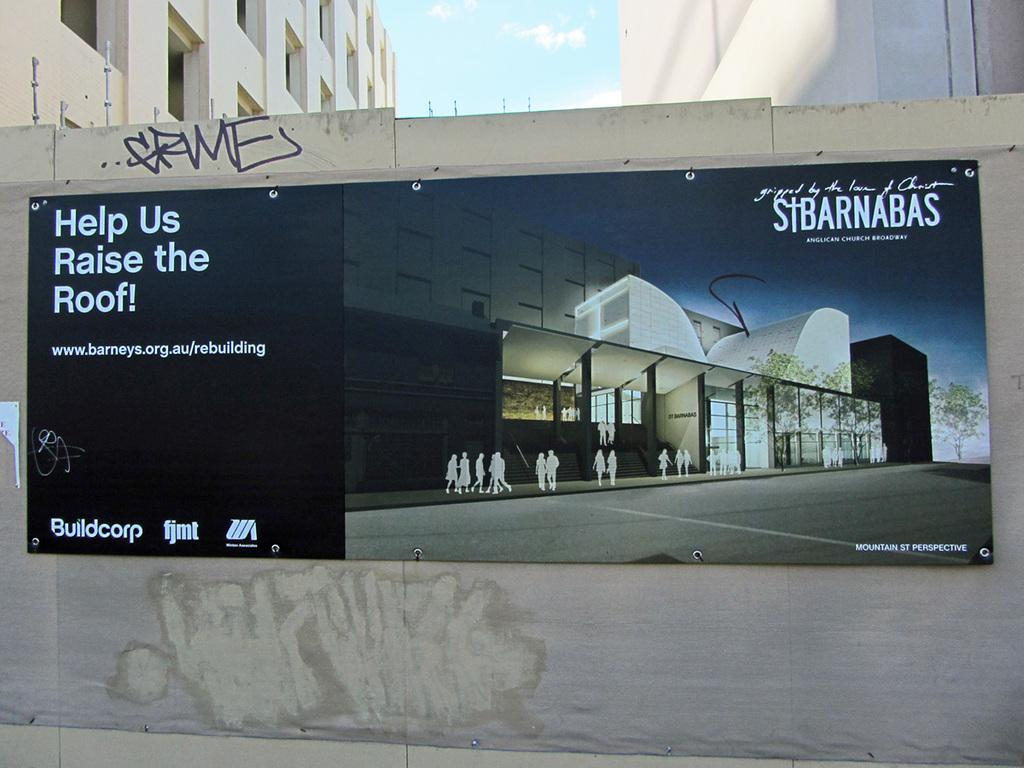<image>
Offer a succinct explanation of the picture presented. A poster outside that reads Help Us raise the roof. 